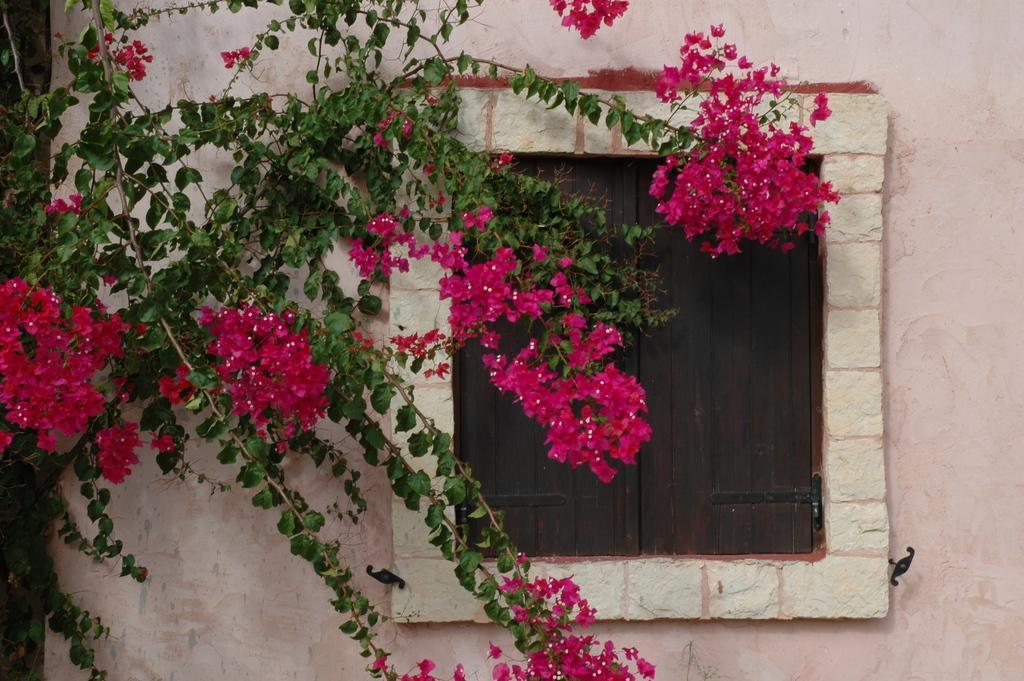In one or two sentences, can you explain what this image depicts? In the image we can see the wall and the window. Here we can see the flowers, pink in color and the leaves. 